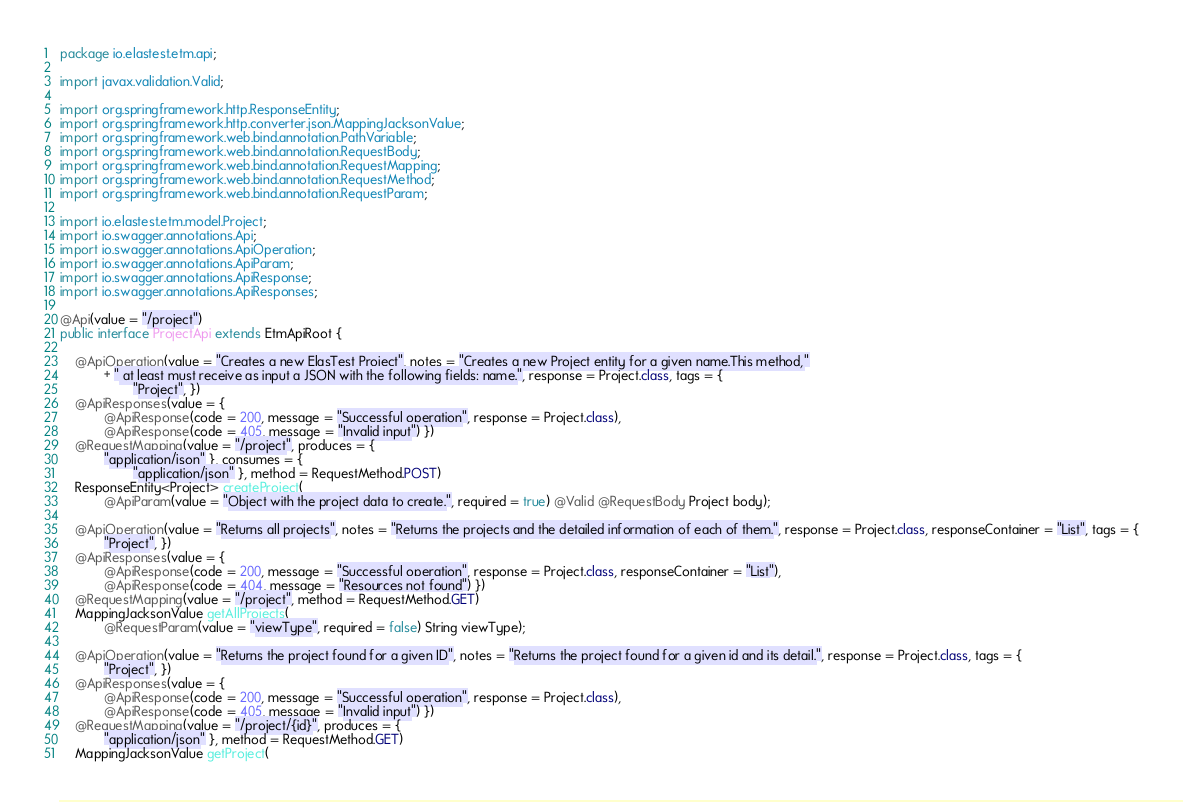<code> <loc_0><loc_0><loc_500><loc_500><_Java_>package io.elastest.etm.api;

import javax.validation.Valid;

import org.springframework.http.ResponseEntity;
import org.springframework.http.converter.json.MappingJacksonValue;
import org.springframework.web.bind.annotation.PathVariable;
import org.springframework.web.bind.annotation.RequestBody;
import org.springframework.web.bind.annotation.RequestMapping;
import org.springframework.web.bind.annotation.RequestMethod;
import org.springframework.web.bind.annotation.RequestParam;

import io.elastest.etm.model.Project;
import io.swagger.annotations.Api;
import io.swagger.annotations.ApiOperation;
import io.swagger.annotations.ApiParam;
import io.swagger.annotations.ApiResponse;
import io.swagger.annotations.ApiResponses;

@Api(value = "/project")
public interface ProjectApi extends EtmApiRoot {

    @ApiOperation(value = "Creates a new ElasTest Project", notes = "Creates a new Project entity for a given name.This method,"
            + " at least must receive as input a JSON with the following fields: name.", response = Project.class, tags = {
                    "Project", })
    @ApiResponses(value = {
            @ApiResponse(code = 200, message = "Successful operation", response = Project.class),
            @ApiResponse(code = 405, message = "Invalid input") })
    @RequestMapping(value = "/project", produces = {
            "application/json" }, consumes = {
                    "application/json" }, method = RequestMethod.POST)
    ResponseEntity<Project> createProject(
            @ApiParam(value = "Object with the project data to create.", required = true) @Valid @RequestBody Project body);

    @ApiOperation(value = "Returns all projects", notes = "Returns the projects and the detailed information of each of them.", response = Project.class, responseContainer = "List", tags = {
            "Project", })
    @ApiResponses(value = {
            @ApiResponse(code = 200, message = "Successful operation", response = Project.class, responseContainer = "List"),
            @ApiResponse(code = 404, message = "Resources not found") })
    @RequestMapping(value = "/project", method = RequestMethod.GET)
    MappingJacksonValue getAllProjects(
            @RequestParam(value = "viewType", required = false) String viewType);

    @ApiOperation(value = "Returns the project found for a given ID", notes = "Returns the project found for a given id and its detail.", response = Project.class, tags = {
            "Project", })
    @ApiResponses(value = {
            @ApiResponse(code = 200, message = "Successful operation", response = Project.class),
            @ApiResponse(code = 405, message = "Invalid input") })
    @RequestMapping(value = "/project/{id}", produces = {
            "application/json" }, method = RequestMethod.GET)
    MappingJacksonValue getProject(</code> 